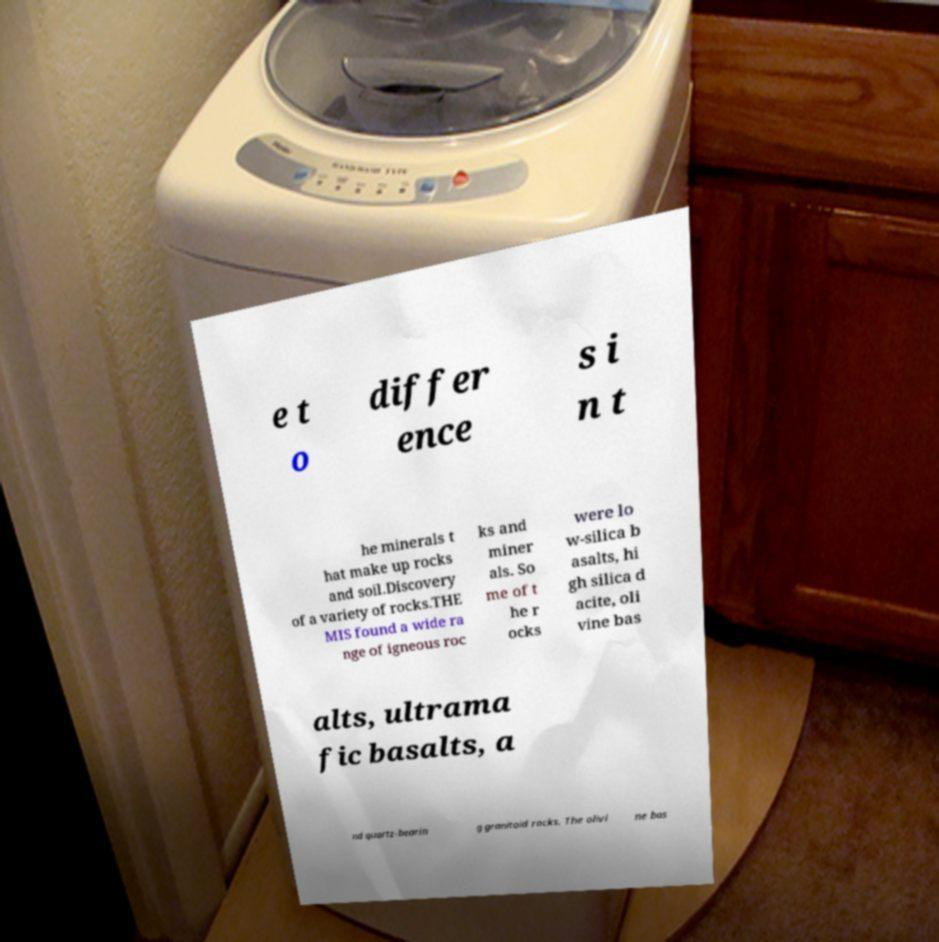Please identify and transcribe the text found in this image. e t o differ ence s i n t he minerals t hat make up rocks and soil.Discovery of a variety of rocks.THE MIS found a wide ra nge of igneous roc ks and miner als. So me of t he r ocks were lo w-silica b asalts, hi gh silica d acite, oli vine bas alts, ultrama fic basalts, a nd quartz-bearin g granitoid rocks. The olivi ne bas 